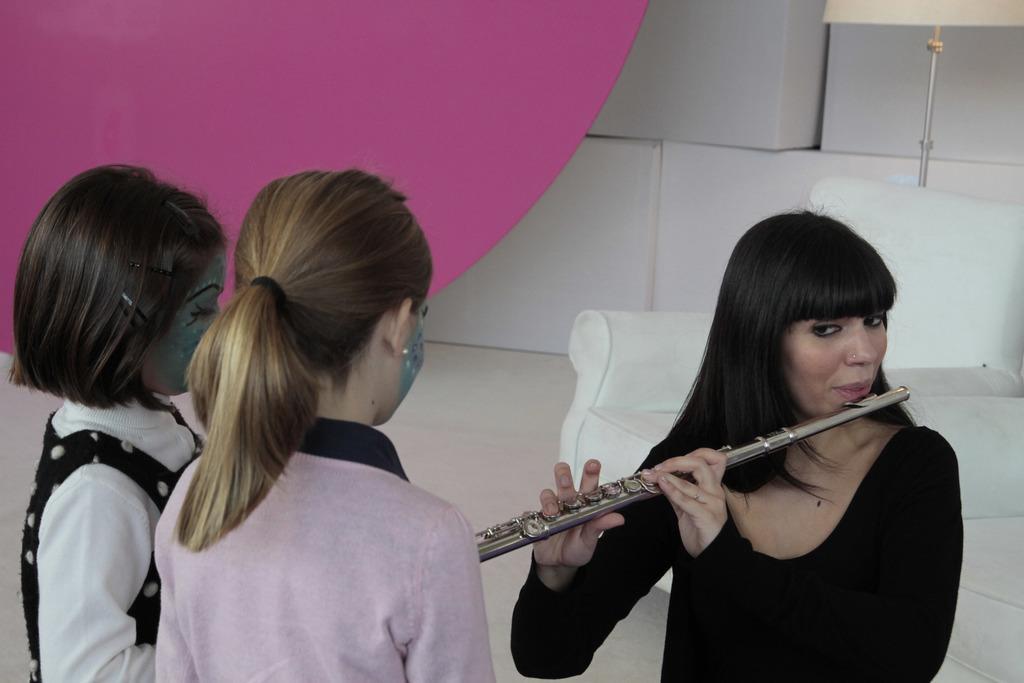Can you describe this image briefly? In this picture we can see three people and a woman is holding a musical instrument and in the background we can see a lamp and some objects. 